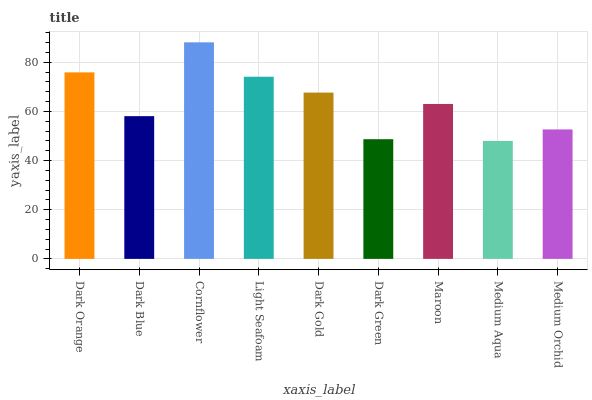Is Medium Aqua the minimum?
Answer yes or no. Yes. Is Cornflower the maximum?
Answer yes or no. Yes. Is Dark Blue the minimum?
Answer yes or no. No. Is Dark Blue the maximum?
Answer yes or no. No. Is Dark Orange greater than Dark Blue?
Answer yes or no. Yes. Is Dark Blue less than Dark Orange?
Answer yes or no. Yes. Is Dark Blue greater than Dark Orange?
Answer yes or no. No. Is Dark Orange less than Dark Blue?
Answer yes or no. No. Is Maroon the high median?
Answer yes or no. Yes. Is Maroon the low median?
Answer yes or no. Yes. Is Medium Aqua the high median?
Answer yes or no. No. Is Cornflower the low median?
Answer yes or no. No. 